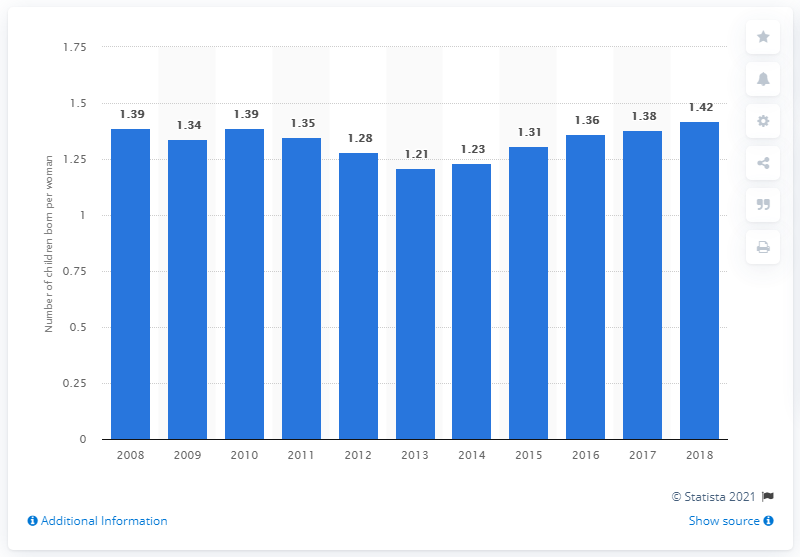What was the fertility rate in Portugal in 2018?
 1.42 